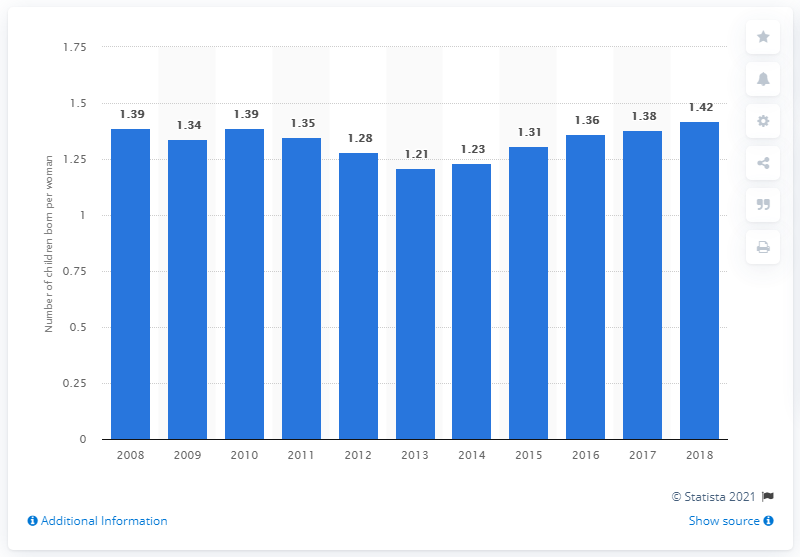What was the fertility rate in Portugal in 2018?
 1.42 